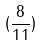<formula> <loc_0><loc_0><loc_500><loc_500>( \frac { 8 } { 1 1 } )</formula> 